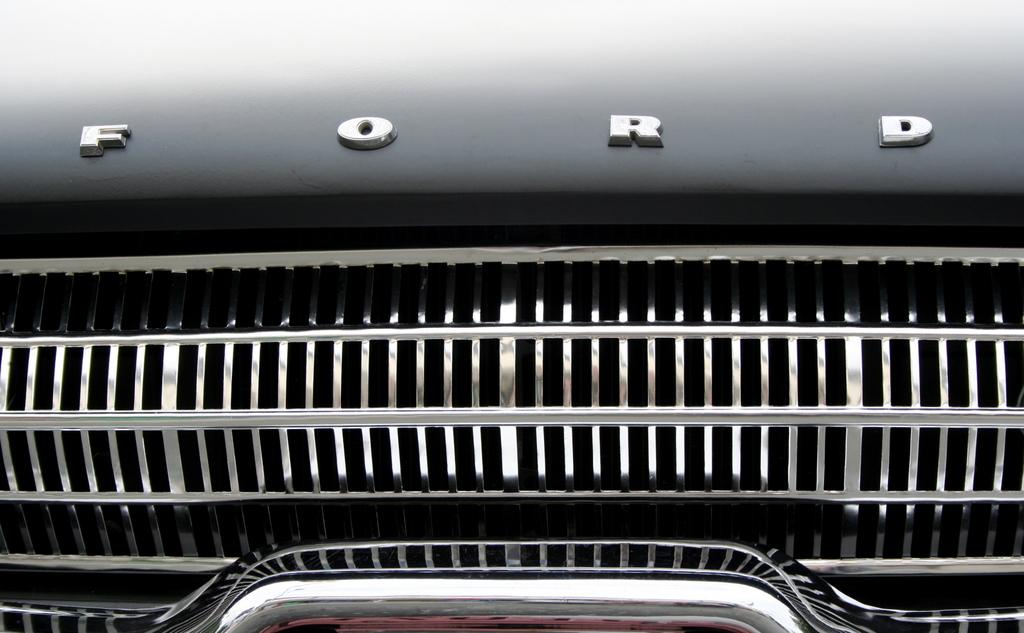What type of car is visible in the image? The image contains a Ford car. How much of the car can be seen in the image? Only the partial front part of the car is visible in the image. What type of honey is being used to clean the car in the image? There is no honey present in the image, nor is there any indication that the car is being cleaned. 